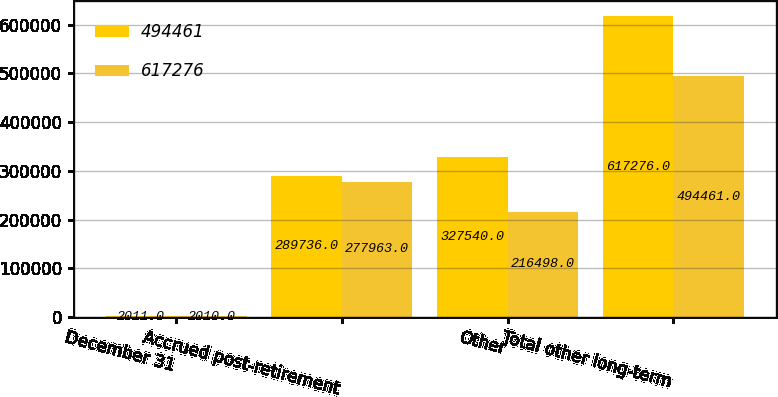Convert chart. <chart><loc_0><loc_0><loc_500><loc_500><stacked_bar_chart><ecel><fcel>December 31<fcel>Accrued post-retirement<fcel>Other<fcel>Total other long-term<nl><fcel>494461<fcel>2011<fcel>289736<fcel>327540<fcel>617276<nl><fcel>617276<fcel>2010<fcel>277963<fcel>216498<fcel>494461<nl></chart> 